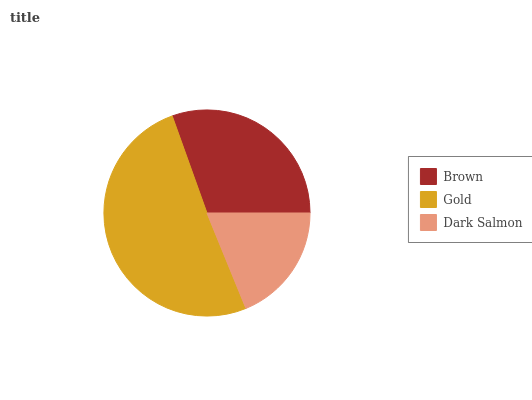Is Dark Salmon the minimum?
Answer yes or no. Yes. Is Gold the maximum?
Answer yes or no. Yes. Is Gold the minimum?
Answer yes or no. No. Is Dark Salmon the maximum?
Answer yes or no. No. Is Gold greater than Dark Salmon?
Answer yes or no. Yes. Is Dark Salmon less than Gold?
Answer yes or no. Yes. Is Dark Salmon greater than Gold?
Answer yes or no. No. Is Gold less than Dark Salmon?
Answer yes or no. No. Is Brown the high median?
Answer yes or no. Yes. Is Brown the low median?
Answer yes or no. Yes. Is Dark Salmon the high median?
Answer yes or no. No. Is Gold the low median?
Answer yes or no. No. 